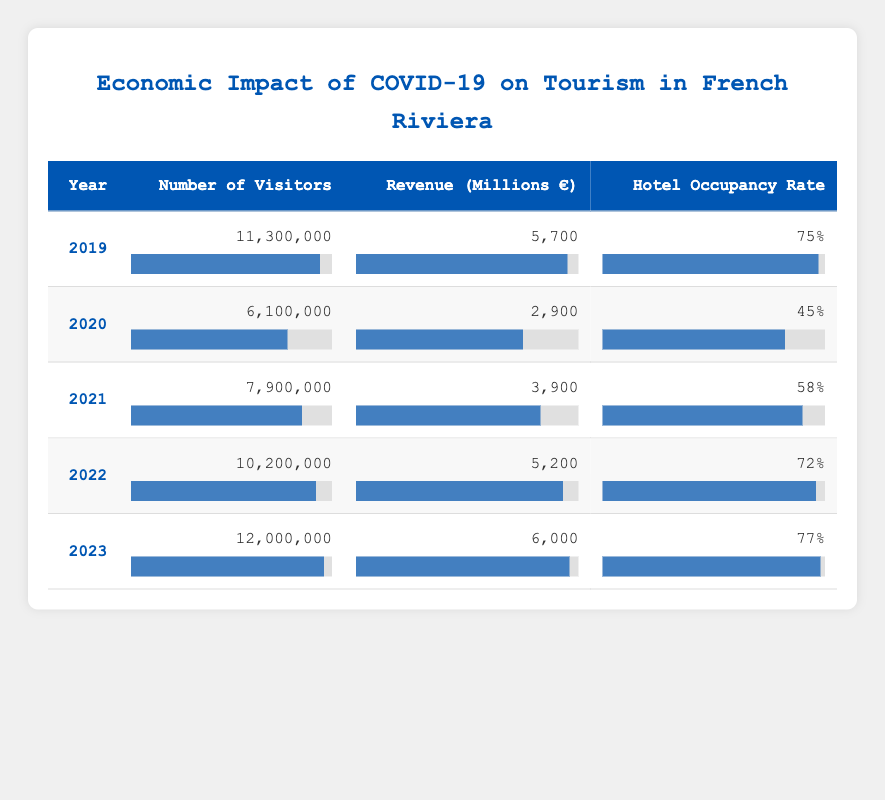What was the hotel occupancy rate in 2020? The table shows that for the year 2020, the hotel occupancy rate is listed as 45%.
Answer: 45% What is the total revenue generated from tourism in the French Riviera from 2019 to 2021? The revenues for the years are: 2019 - 5700 million, 2020 - 2900 million, and 2021 - 3900 million. Adding these amounts together gives: 5700 + 2900 + 3900 = 12500 million.
Answer: 12500 million Did the number of visitors in 2022 exceed that of 2021? The table states that there were 7900000 visitors in 2021 and 10200000 in 2022. Since 10200000 is greater than 7900000, the answer is yes.
Answer: Yes What year had the highest number of visitors, and how many were there? According to the table, the year with the highest number of visitors is 2023 with 12000000 visitors.
Answer: 2023, 12000000 What is the percentage increase in revenue from 2020 to 2023? The revenue in 2020 was 2900 million, and in 2023 it is 6000 million. The increase is 6000 - 2900 = 3100 million. The percentage increase is (3100 / 2900) * 100 = 106.90%.
Answer: 106.90% 